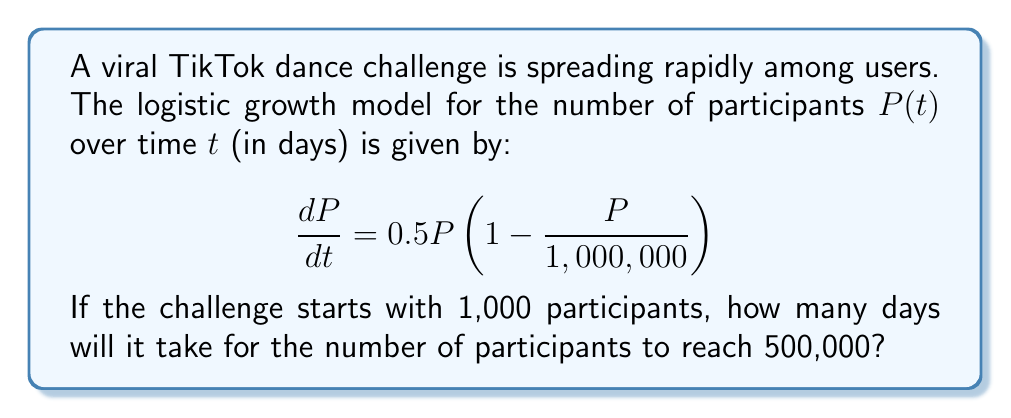Can you solve this math problem? Let's solve this step-by-step:

1) The logistic growth equation is given by:
   $$\frac{dP}{dt} = rP\left(1 - \frac{P}{K}\right)$$
   where $r$ is the growth rate and $K$ is the carrying capacity.

2) In our case, $r = 0.5$ and $K = 1,000,000$.

3) The solution to this equation is:
   $$P(t) = \frac{K}{1 + \left(\frac{K}{P_0} - 1\right)e^{-rt}}$$
   where $P_0$ is the initial population.

4) Substituting our values:
   $$P(t) = \frac{1,000,000}{1 + \left(\frac{1,000,000}{1,000} - 1\right)e^{-0.5t}}$$

5) We want to find $t$ when $P(t) = 500,000$. Let's substitute this:
   $$500,000 = \frac{1,000,000}{1 + 999e^{-0.5t}}$$

6) Solving for $t$:
   $$\frac{1,000,000}{500,000} = 1 + 999e^{-0.5t}$$
   $$2 = 1 + 999e^{-0.5t}$$
   $$1 = 999e^{-0.5t}$$
   $$\frac{1}{999} = e^{-0.5t}$$
   $$\ln\left(\frac{1}{999}\right) = -0.5t$$
   $$t = -2\ln\left(\frac{1}{999}\right) \approx 13.82$$

7) Since we're dealing with days, we round up to the nearest whole number.
Answer: 14 days 